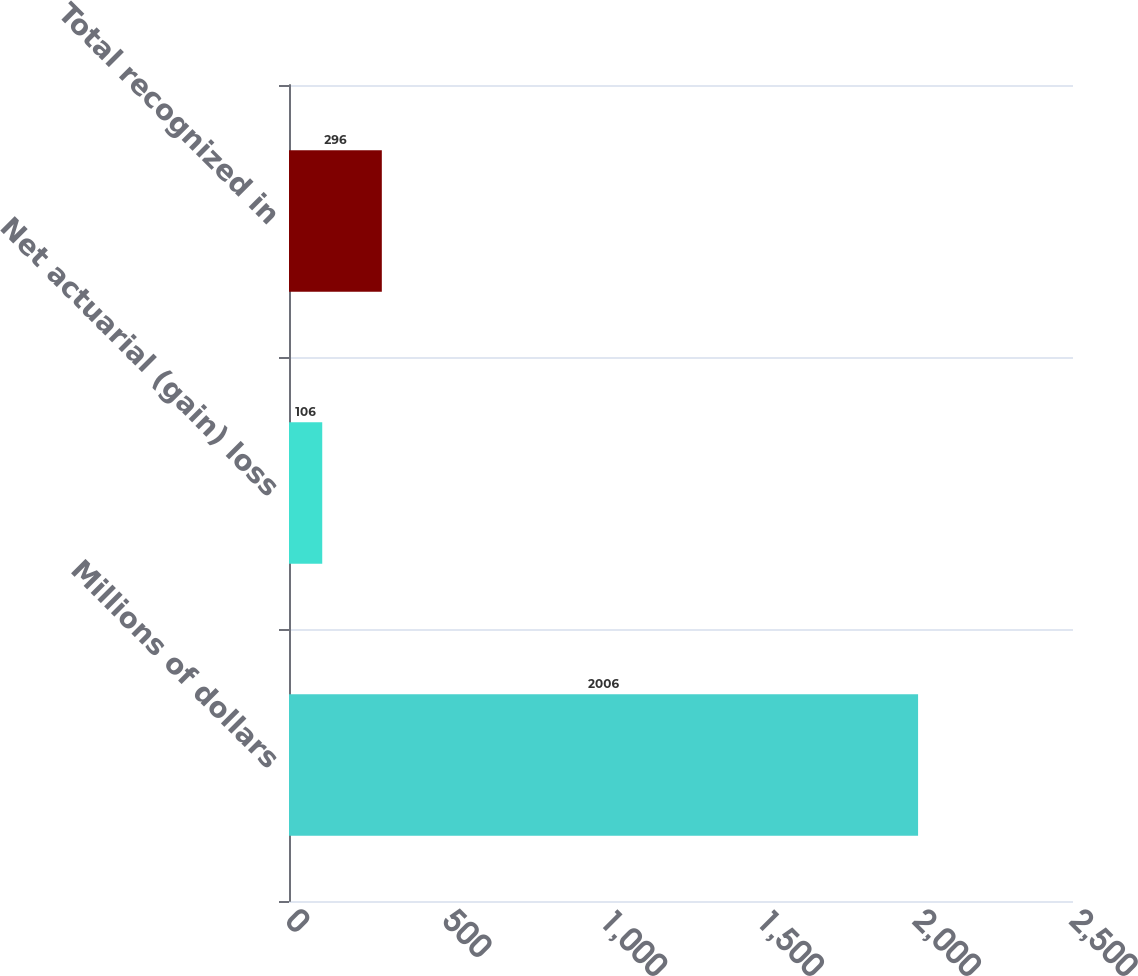Convert chart. <chart><loc_0><loc_0><loc_500><loc_500><bar_chart><fcel>Millions of dollars<fcel>Net actuarial (gain) loss<fcel>Total recognized in<nl><fcel>2006<fcel>106<fcel>296<nl></chart> 